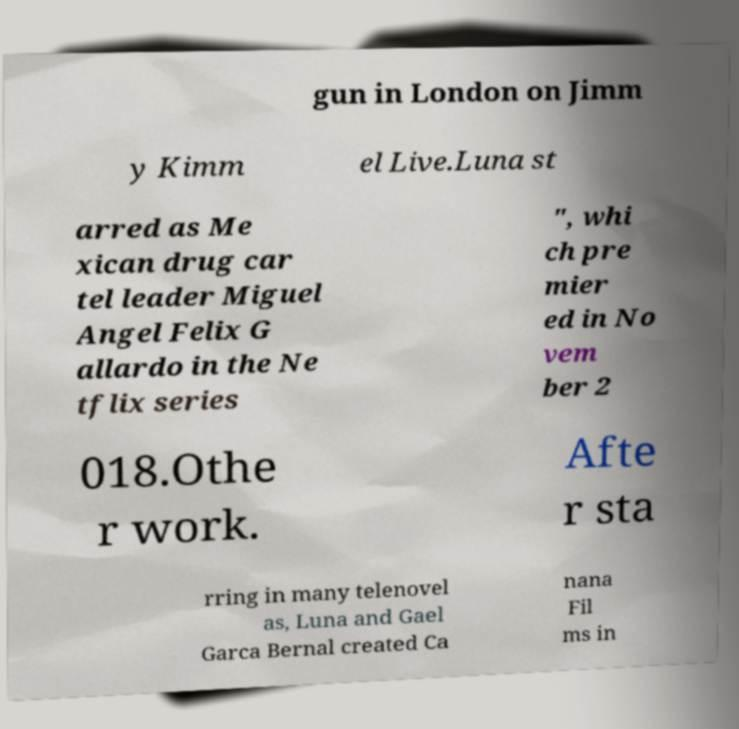For documentation purposes, I need the text within this image transcribed. Could you provide that? gun in London on Jimm y Kimm el Live.Luna st arred as Me xican drug car tel leader Miguel Angel Felix G allardo in the Ne tflix series ", whi ch pre mier ed in No vem ber 2 018.Othe r work. Afte r sta rring in many telenovel as, Luna and Gael Garca Bernal created Ca nana Fil ms in 